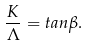<formula> <loc_0><loc_0><loc_500><loc_500>\frac { K } { \Lambda } = t a n \beta .</formula> 